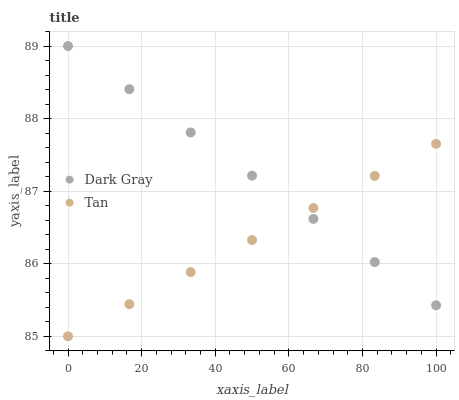Does Tan have the minimum area under the curve?
Answer yes or no. Yes. Does Dark Gray have the maximum area under the curve?
Answer yes or no. Yes. Does Tan have the maximum area under the curve?
Answer yes or no. No. Is Dark Gray the smoothest?
Answer yes or no. Yes. Is Tan the roughest?
Answer yes or no. Yes. Is Tan the smoothest?
Answer yes or no. No. Does Tan have the lowest value?
Answer yes or no. Yes. Does Dark Gray have the highest value?
Answer yes or no. Yes. Does Tan have the highest value?
Answer yes or no. No. Does Dark Gray intersect Tan?
Answer yes or no. Yes. Is Dark Gray less than Tan?
Answer yes or no. No. Is Dark Gray greater than Tan?
Answer yes or no. No. 